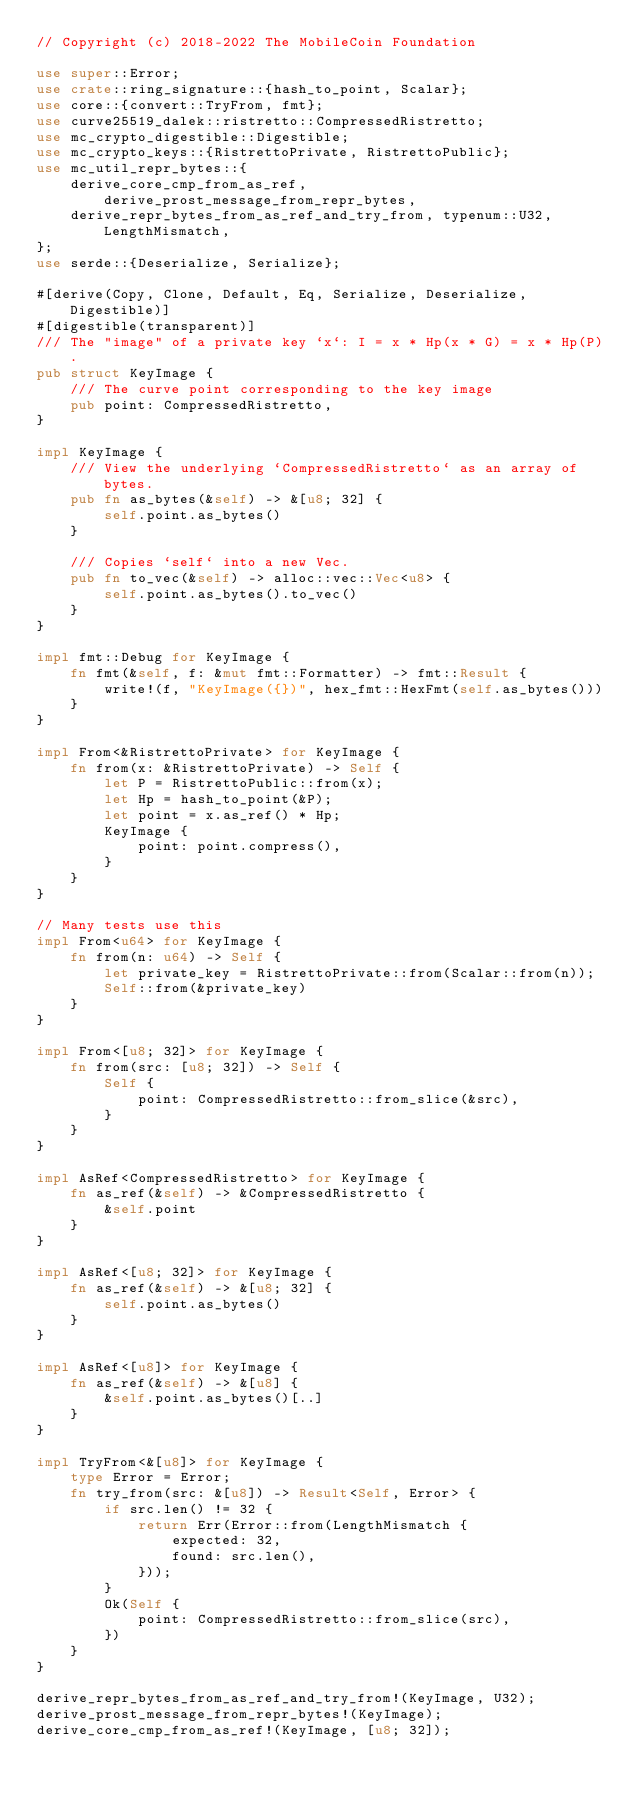<code> <loc_0><loc_0><loc_500><loc_500><_Rust_>// Copyright (c) 2018-2022 The MobileCoin Foundation

use super::Error;
use crate::ring_signature::{hash_to_point, Scalar};
use core::{convert::TryFrom, fmt};
use curve25519_dalek::ristretto::CompressedRistretto;
use mc_crypto_digestible::Digestible;
use mc_crypto_keys::{RistrettoPrivate, RistrettoPublic};
use mc_util_repr_bytes::{
    derive_core_cmp_from_as_ref, derive_prost_message_from_repr_bytes,
    derive_repr_bytes_from_as_ref_and_try_from, typenum::U32, LengthMismatch,
};
use serde::{Deserialize, Serialize};

#[derive(Copy, Clone, Default, Eq, Serialize, Deserialize, Digestible)]
#[digestible(transparent)]
/// The "image" of a private key `x`: I = x * Hp(x * G) = x * Hp(P).
pub struct KeyImage {
    /// The curve point corresponding to the key image
    pub point: CompressedRistretto,
}

impl KeyImage {
    /// View the underlying `CompressedRistretto` as an array of bytes.
    pub fn as_bytes(&self) -> &[u8; 32] {
        self.point.as_bytes()
    }

    /// Copies `self` into a new Vec.
    pub fn to_vec(&self) -> alloc::vec::Vec<u8> {
        self.point.as_bytes().to_vec()
    }
}

impl fmt::Debug for KeyImage {
    fn fmt(&self, f: &mut fmt::Formatter) -> fmt::Result {
        write!(f, "KeyImage({})", hex_fmt::HexFmt(self.as_bytes()))
    }
}

impl From<&RistrettoPrivate> for KeyImage {
    fn from(x: &RistrettoPrivate) -> Self {
        let P = RistrettoPublic::from(x);
        let Hp = hash_to_point(&P);
        let point = x.as_ref() * Hp;
        KeyImage {
            point: point.compress(),
        }
    }
}

// Many tests use this
impl From<u64> for KeyImage {
    fn from(n: u64) -> Self {
        let private_key = RistrettoPrivate::from(Scalar::from(n));
        Self::from(&private_key)
    }
}

impl From<[u8; 32]> for KeyImage {
    fn from(src: [u8; 32]) -> Self {
        Self {
            point: CompressedRistretto::from_slice(&src),
        }
    }
}

impl AsRef<CompressedRistretto> for KeyImage {
    fn as_ref(&self) -> &CompressedRistretto {
        &self.point
    }
}

impl AsRef<[u8; 32]> for KeyImage {
    fn as_ref(&self) -> &[u8; 32] {
        self.point.as_bytes()
    }
}

impl AsRef<[u8]> for KeyImage {
    fn as_ref(&self) -> &[u8] {
        &self.point.as_bytes()[..]
    }
}

impl TryFrom<&[u8]> for KeyImage {
    type Error = Error;
    fn try_from(src: &[u8]) -> Result<Self, Error> {
        if src.len() != 32 {
            return Err(Error::from(LengthMismatch {
                expected: 32,
                found: src.len(),
            }));
        }
        Ok(Self {
            point: CompressedRistretto::from_slice(src),
        })
    }
}

derive_repr_bytes_from_as_ref_and_try_from!(KeyImage, U32);
derive_prost_message_from_repr_bytes!(KeyImage);
derive_core_cmp_from_as_ref!(KeyImage, [u8; 32]);
</code> 